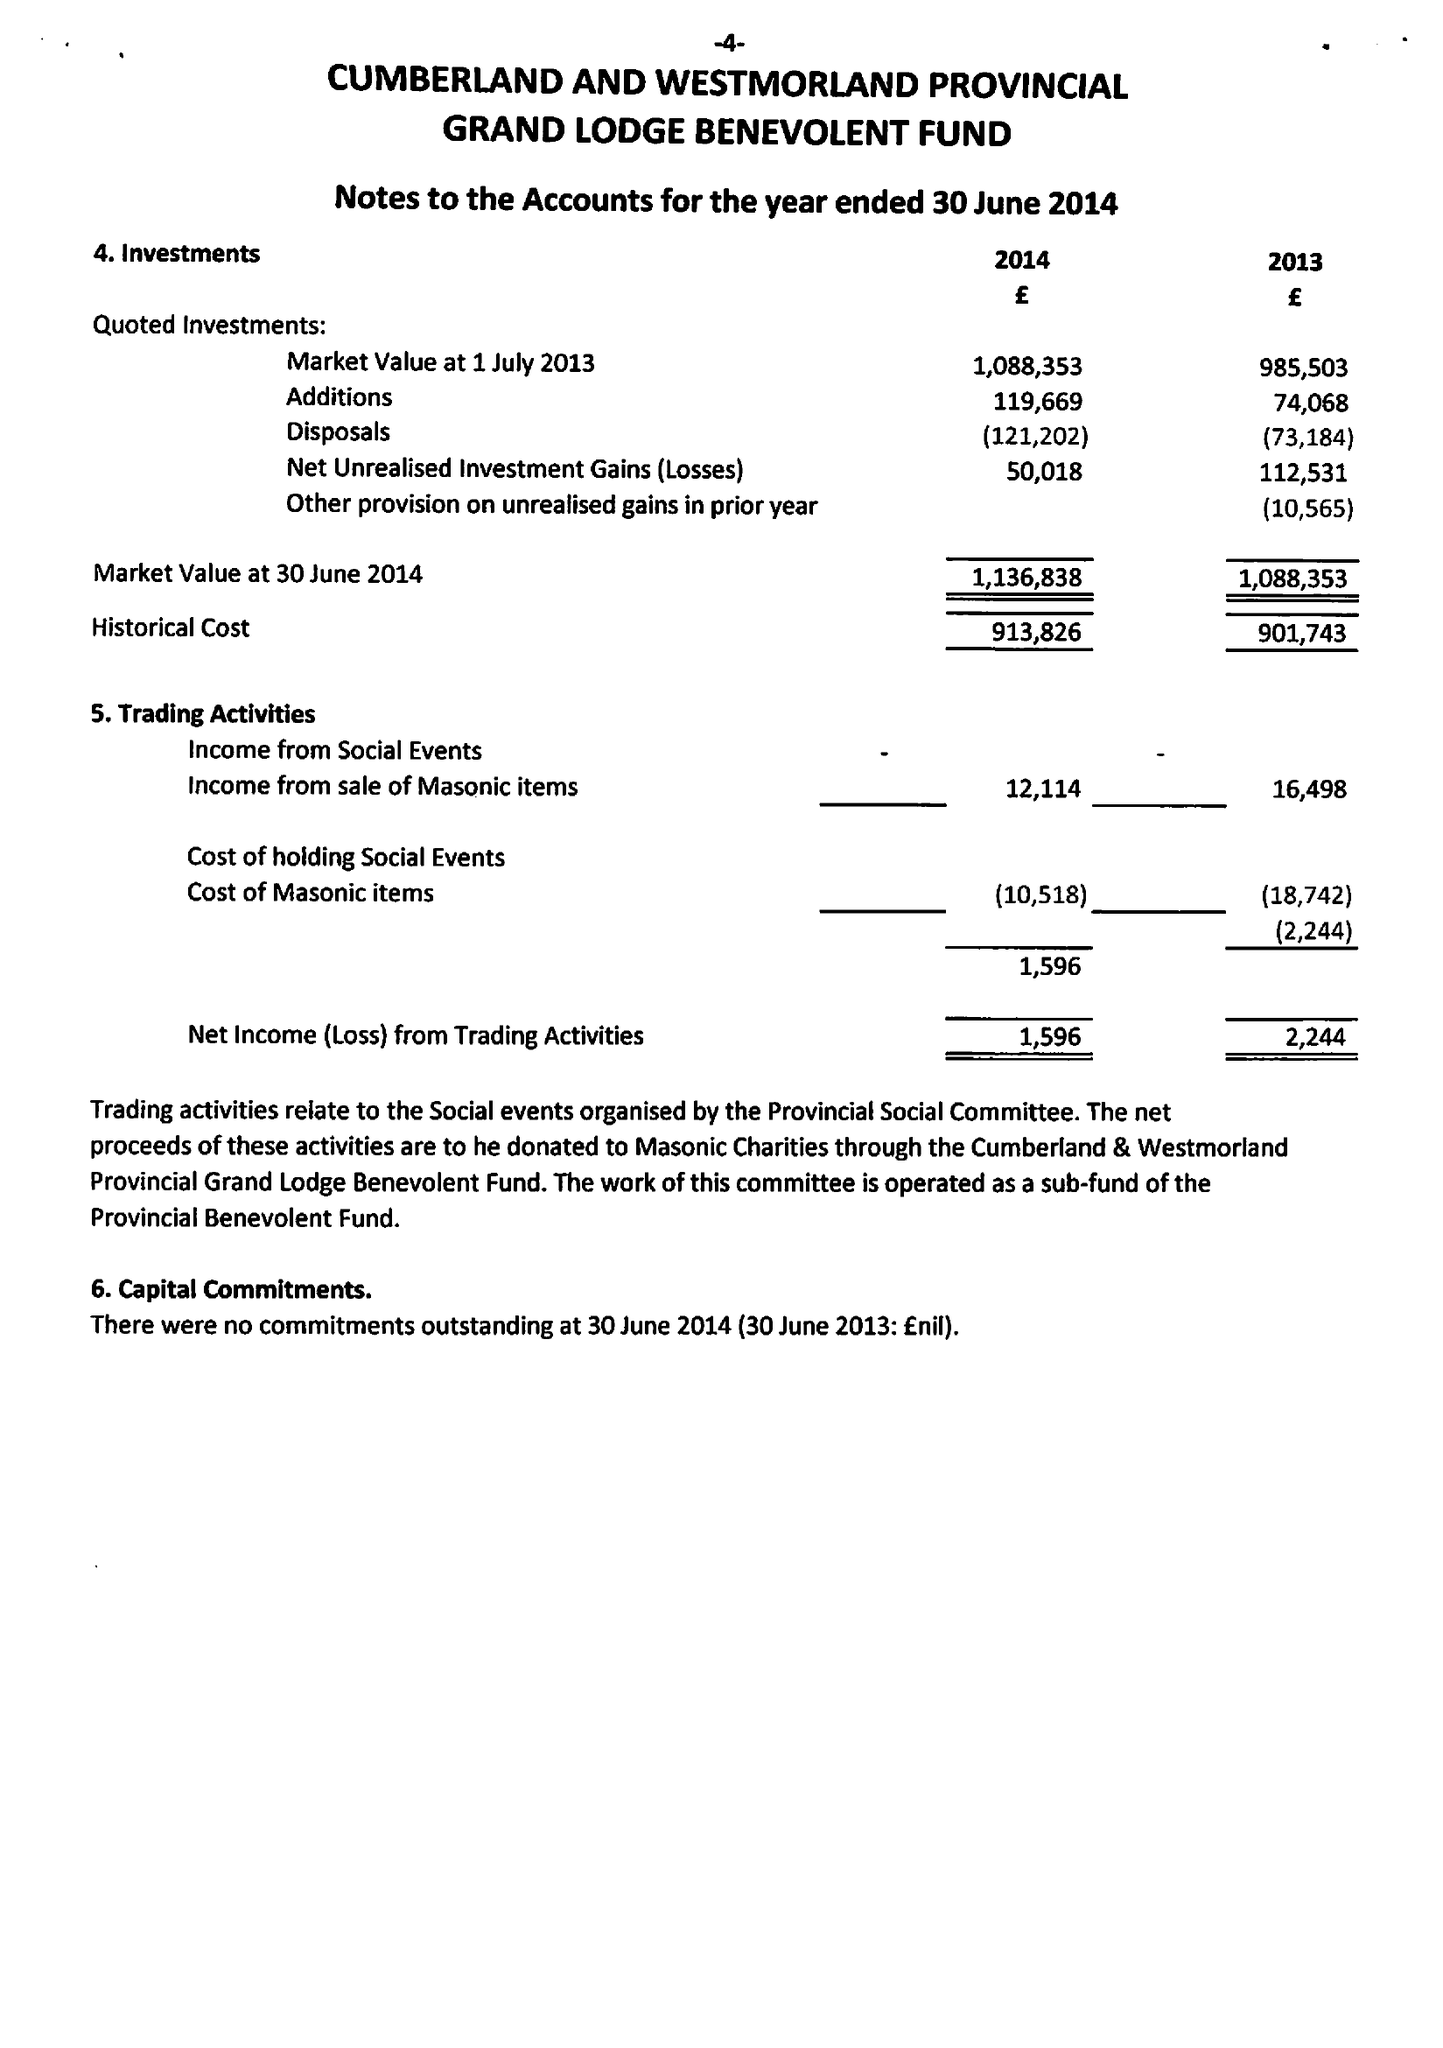What is the value for the address__postcode?
Answer the question using a single word or phrase. CA5 7HS 